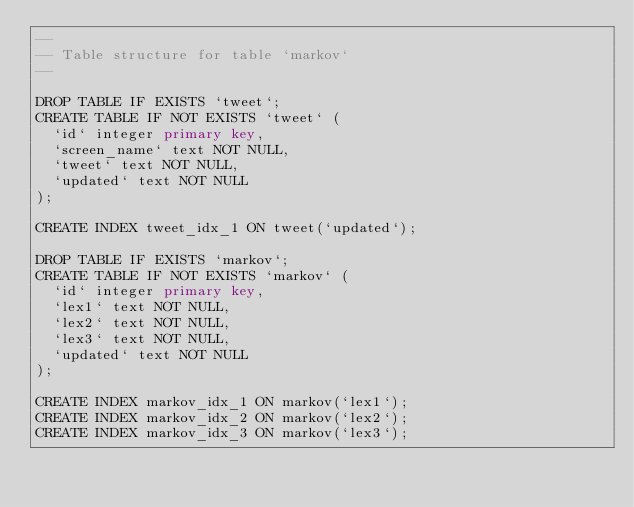<code> <loc_0><loc_0><loc_500><loc_500><_SQL_>--
-- Table structure for table `markov`
--

DROP TABLE IF EXISTS `tweet`;
CREATE TABLE IF NOT EXISTS `tweet` (
  `id` integer primary key,
  `screen_name` text NOT NULL,
  `tweet` text NOT NULL,
  `updated` text NOT NULL
);

CREATE INDEX tweet_idx_1 ON tweet(`updated`);

DROP TABLE IF EXISTS `markov`;
CREATE TABLE IF NOT EXISTS `markov` (
  `id` integer primary key,
  `lex1` text NOT NULL,
  `lex2` text NOT NULL,
  `lex3` text NOT NULL,
  `updated` text NOT NULL
);

CREATE INDEX markov_idx_1 ON markov(`lex1`);
CREATE INDEX markov_idx_2 ON markov(`lex2`);
CREATE INDEX markov_idx_3 ON markov(`lex3`);</code> 